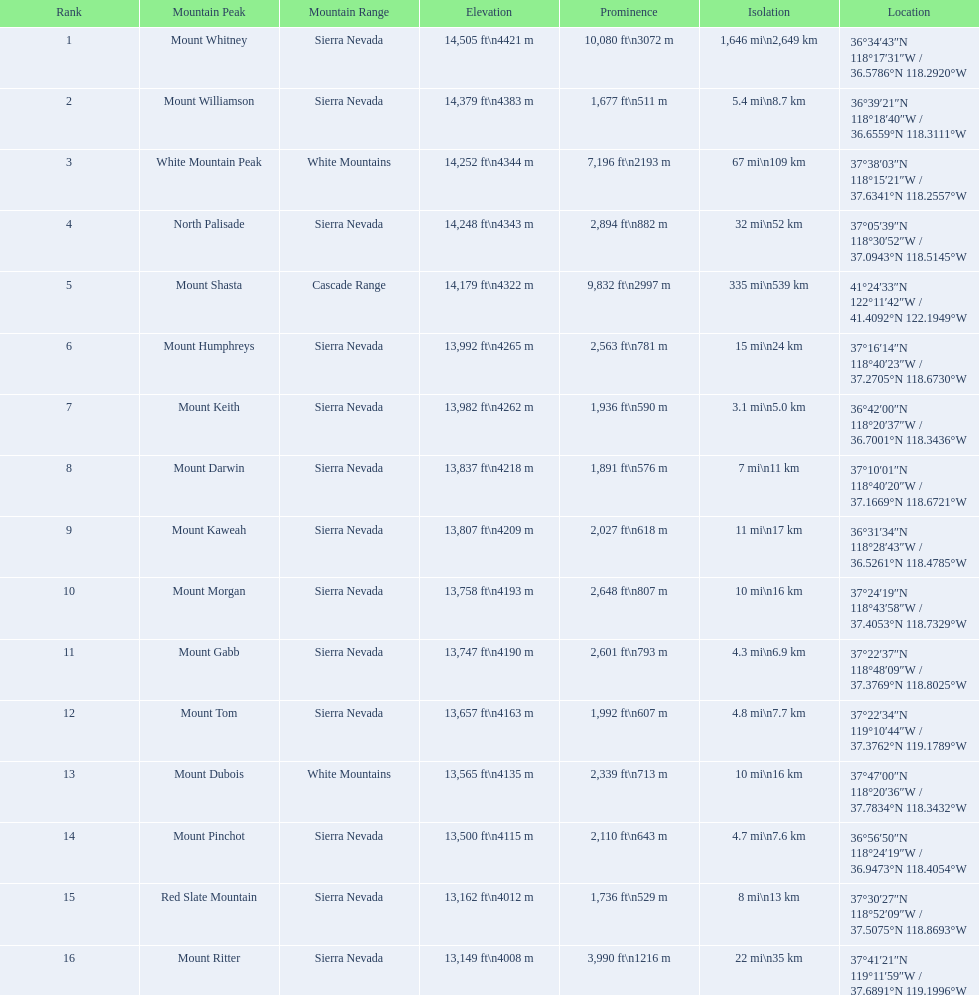What are the mountain summits? Mount Whitney, Mount Williamson, White Mountain Peak, North Palisade, Mount Shasta, Mount Humphreys, Mount Keith, Mount Darwin, Mount Kaweah, Mount Morgan, Mount Gabb, Mount Tom, Mount Dubois, Mount Pinchot, Red Slate Mountain, Mount Ritter. Of these, which one has a prominence exceeding 10,000 ft? Mount Whitney. 